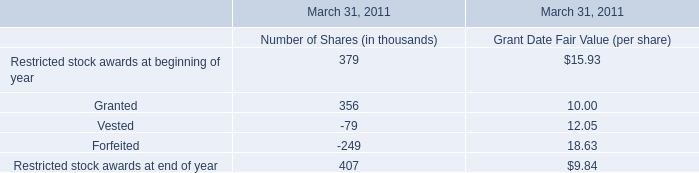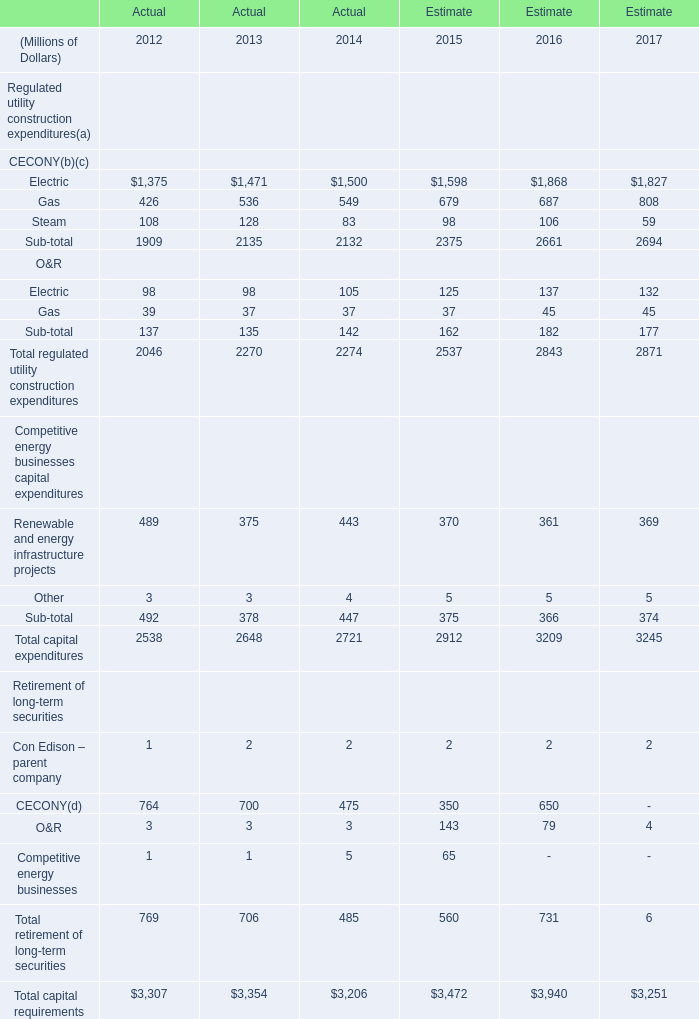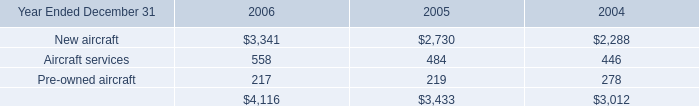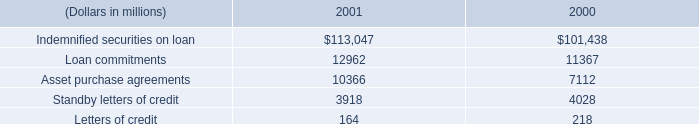What is the average amount of Electric of Estimate 2017, and New aircraft of 2006 ? 
Computations: ((1827.0 + 3341.0) / 2)
Answer: 2584.0. 